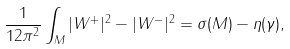<formula> <loc_0><loc_0><loc_500><loc_500>\frac { 1 } { 1 2 \pi ^ { 2 } } \int _ { M } | W ^ { + } | ^ { 2 } - | W ^ { - } | ^ { 2 } = \sigma ( M ) - \eta ( \gamma ) ,</formula> 